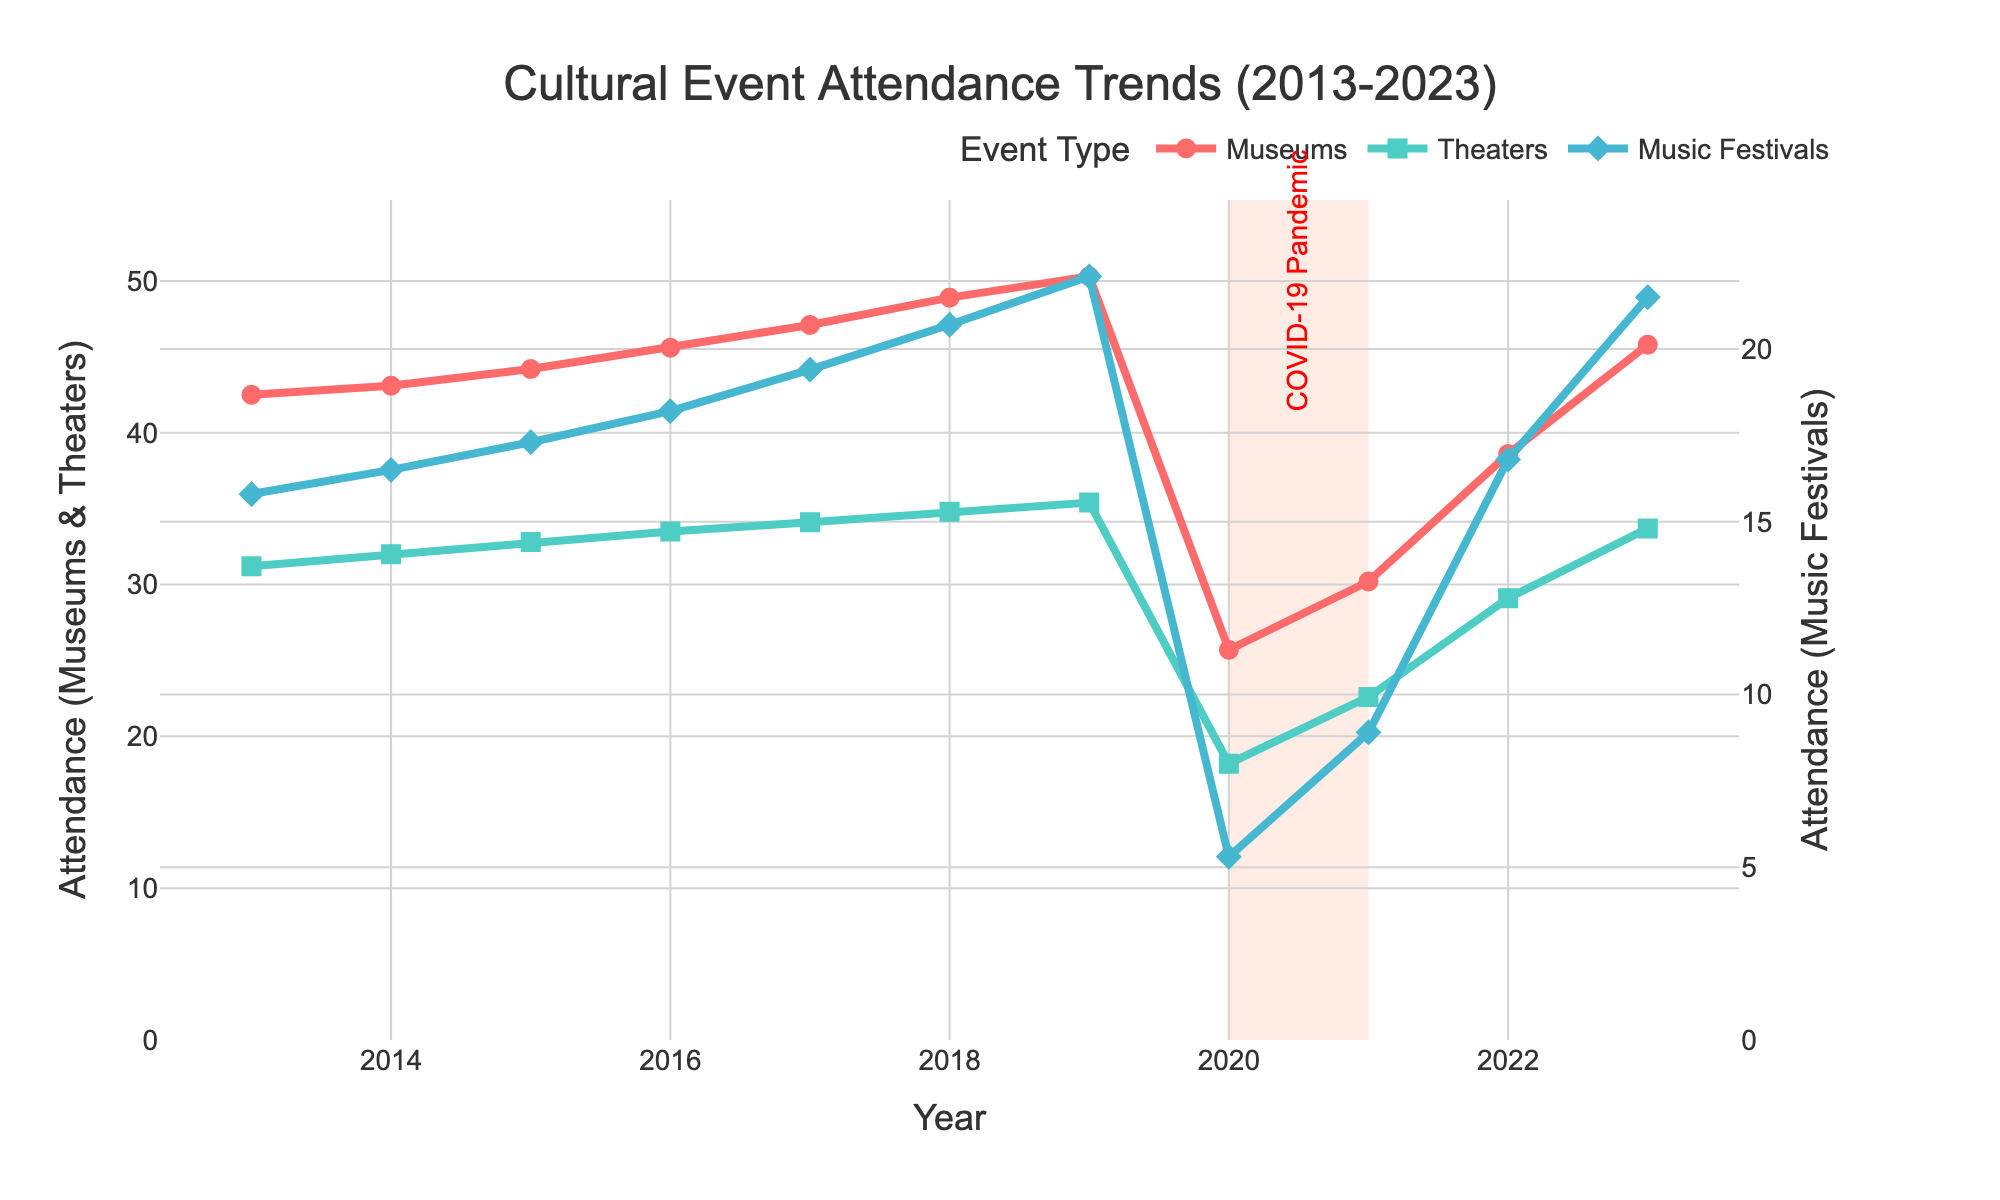How did attendance at theaters change from 2013 to 2023? To determine the change in attendance at theaters from 2013 to 2023, we subtract the attendance in 2013 from the attendance in 2023: 33.7 - 31.2. The attendance increased by 2.5 million people.
Answer: Increased by 2.5 million people Which event type saw the largest drop in attendance during the COVID-19 pandemic period (2020-2021)? Music Festivals had the largest drop during the COVID-19 period, going from 22.1 million in 2019 to 5.3 million in 2020, a drop of 16.8 million, and a minimal rise to 8.9 million in 2021.
Answer: Music Festivals What was the average attendance at museums between 2013 and 2023? To find the average, sum the annual attendances from 2013 to 2023 and divide by the number of years: \((42.5+43.1+44.2+45.6+47.1+48.9+50.3+25.7+30.2+38.6+45.8)/11=\approx 41.2\).
Answer: Approximately 41.2 million Compare the attendance trend of museums and theaters during the pandemic period. Museums and theaters both saw a sharp decline in attendance during the pandemic. Museums fell from 50.3 million in 2019 to 25.7 million in 2020, whereas theaters fell from 35.4 million in 2019 to 18.2 million in 2020, showing a similar trend of almost halving their numbers.
Answer: Both saw sharp declines Which event type had the most stable attendance trend over the decade? Theaters had the most stable trend, shown by smaller year-to-year changes compared to the other event types. From 31.2 million in 2013 to 33.7 million in 2023 shows more consistent attendance levels.
Answer: Theaters In which year did music festivals reach their peak attendance? To find the peak attendance for music festivals, look at the highest data point on the line corresponding to music festivals. The highest value is in 2019 at 22.1 million.
Answer: 2019 What was the combined attendance for museums and theaters in 2017? To find the combined attendance for museums and theaters in 2017, add the two values together: 47.1+34.1 = 81.2 million.
Answer: 81.2 million By how much did museum attendance increase from the lowest point during the COVID-19 pandemic to 2023? The lowest point during the pandemic for museums was in 2020 at 25.7 million, and it increased to 45.8 million in 2023. The difference is 45.8 - 25.7 = 20.1 million.
Answer: Increased by 20.1 million How did the attendance trends for music festivals and theaters compare from 2022 to 2023? Attendance for music festivals increased from 16.8 million in 2022 to 21.5 million in 2023, while theater attendance increased from 29.1 million in 2022 to 33.7 million in 2023. Both event types showed a noticeable increase.
Answer: Music festivals and theaters both increased 